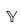Convert formula to latex. <formula><loc_0><loc_0><loc_500><loc_500>\mathbb { Y }</formula> 